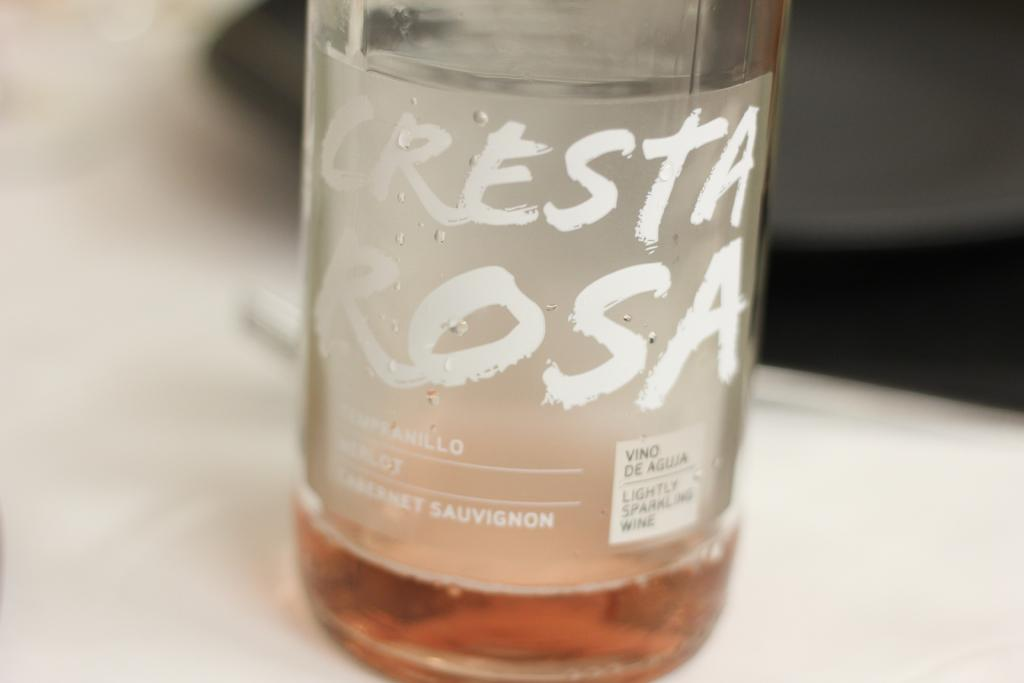Provide a one-sentence caption for the provided image. A bottle of Cresta Rosa is sitting on a table by a plate. 